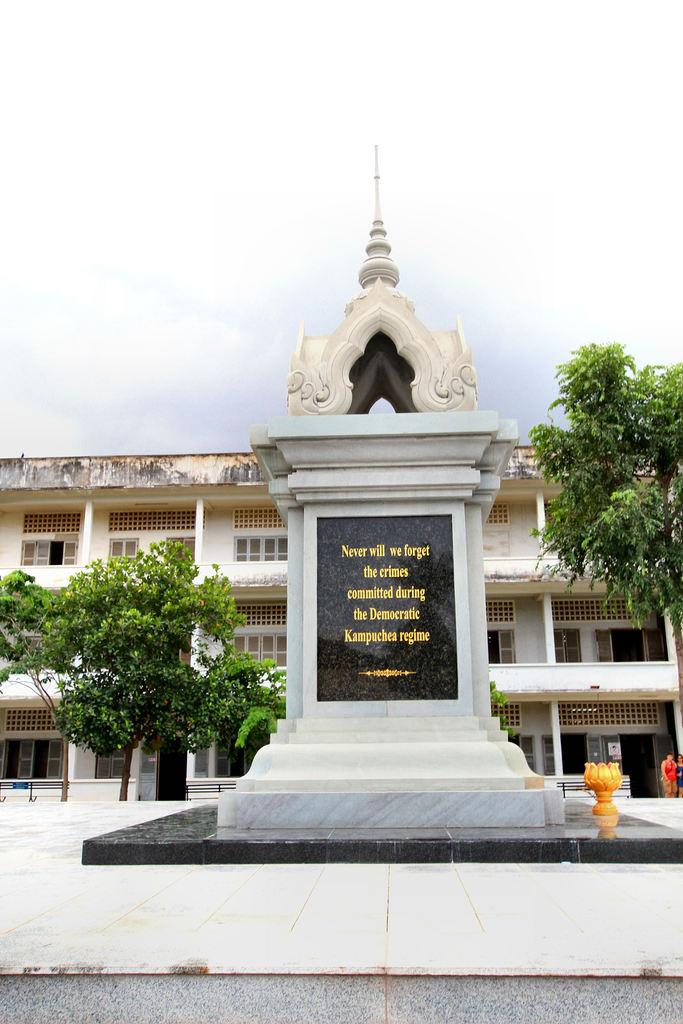<image>
Present a compact description of the photo's key features. A white stone monument reading "Never will we forget the crimes committed during the Democratic Kampuchea regime." 